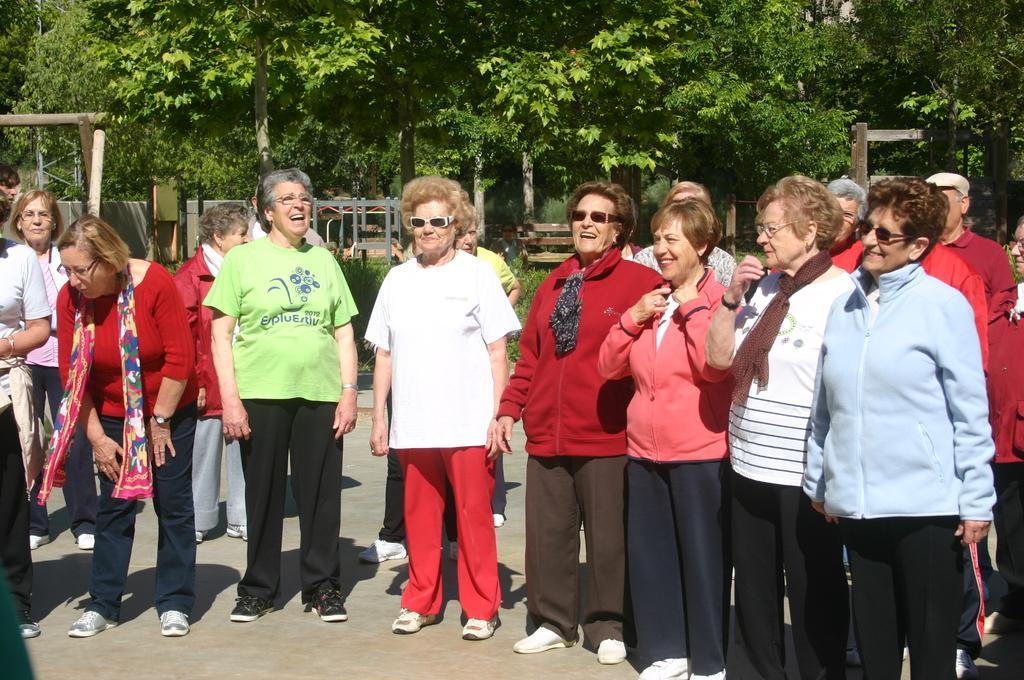Can you describe this image briefly? In this image I can see there are group of people standing on road ,at the top I can see trees, bench visible in the middle. 